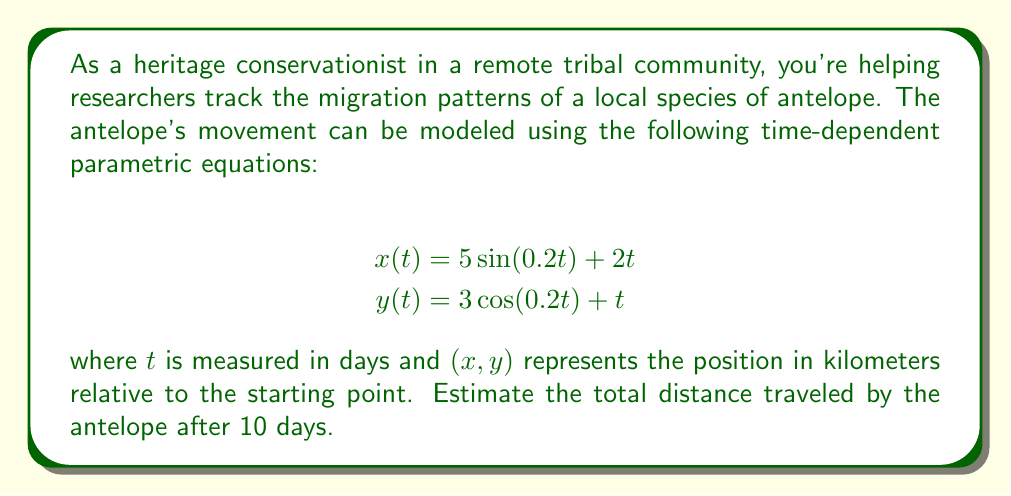Provide a solution to this math problem. To solve this problem, we need to follow these steps:

1) First, we need to understand that the position of the antelope at any time $t$ is given by $(x(t), y(t))$.

2) To find the total distance traveled, we need to calculate the length of the path. This can be done by integrating the speed of the antelope over time.

3) The speed at any time $t$ is given by the magnitude of the velocity vector:

   $$v(t) = \sqrt{\left(\frac{dx}{dt}\right)^2 + \left(\frac{dy}{dt}\right)^2}$$

4) Let's calculate $\frac{dx}{dt}$ and $\frac{dy}{dt}$:

   $$\frac{dx}{dt} = \cos(0.2t) + 2$$
   $$\frac{dy}{dt} = -0.6\sin(0.2t) + 1$$

5) Now we can express $v(t)$:

   $$v(t) = \sqrt{(\cos(0.2t) + 2)^2 + (-0.6\sin(0.2t) + 1)^2}$$

6) The total distance traveled is the integral of speed over time:

   $$\text{Distance} = \int_0^{10} \sqrt{(\cos(0.2t) + 2)^2 + (-0.6\sin(0.2t) + 1)^2} \, dt$$

7) This integral is too complex to solve analytically. We need to use numerical integration methods to estimate it. Using a computer algebra system or numerical integration tool, we can estimate this integral.

8) The result of this numerical integration is approximately 24.7 km.
Answer: The estimated total distance traveled by the antelope after 10 days is approximately 24.7 kilometers. 